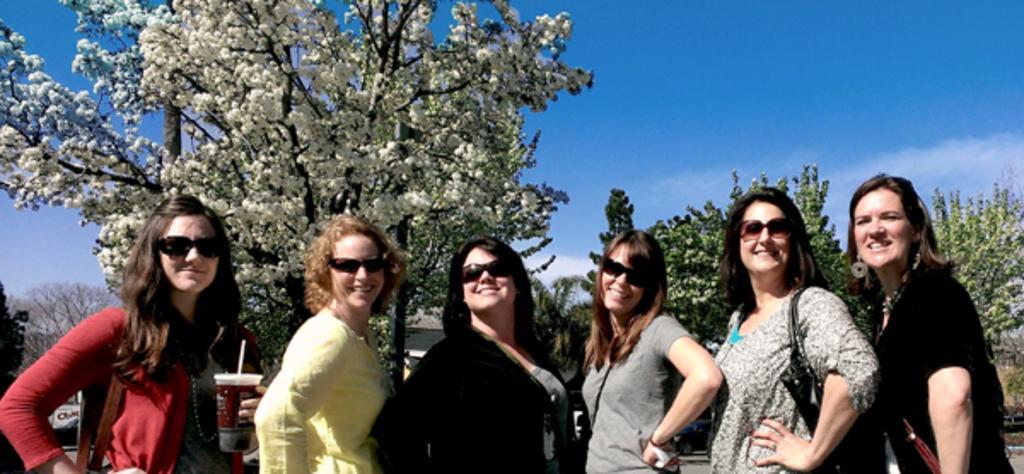Please provide a concise description of this image. In this image I can see group of people standing. The person at left holding a glass, background I can see trees in white and green color, sky in white and blue color. 